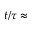Convert formula to latex. <formula><loc_0><loc_0><loc_500><loc_500>t / \tau \approx</formula> 